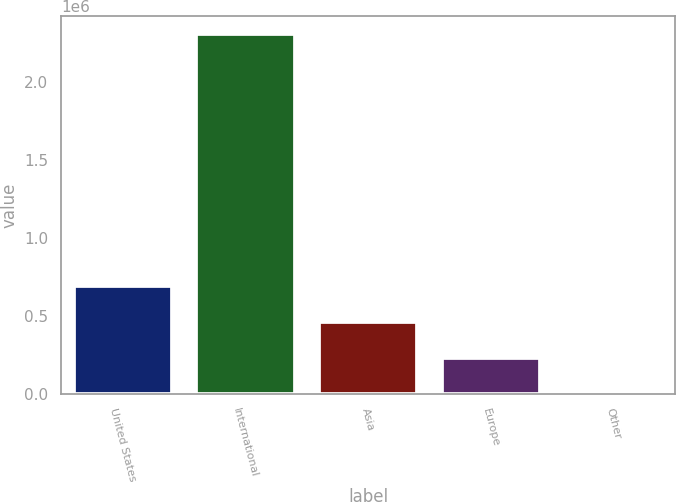Convert chart to OTSL. <chart><loc_0><loc_0><loc_500><loc_500><bar_chart><fcel>United States<fcel>International<fcel>Asia<fcel>Europe<fcel>Other<nl><fcel>691320<fcel>2.3044e+06<fcel>460880<fcel>230441<fcel>1<nl></chart> 